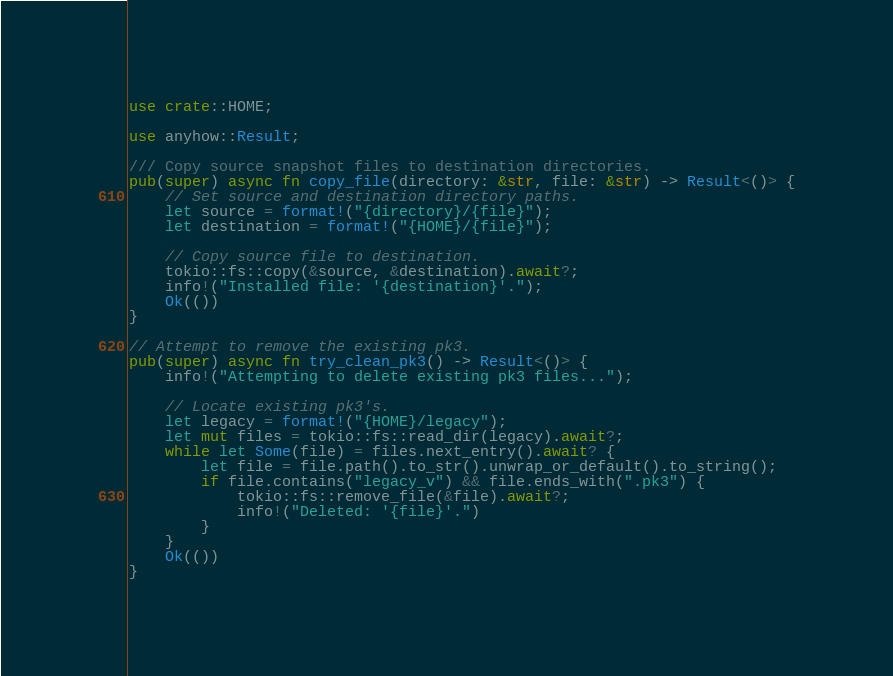Convert code to text. <code><loc_0><loc_0><loc_500><loc_500><_Rust_>use crate::HOME;

use anyhow::Result;

/// Copy source snapshot files to destination directories.
pub(super) async fn copy_file(directory: &str, file: &str) -> Result<()> {
    // Set source and destination directory paths.
    let source = format!("{directory}/{file}");
    let destination = format!("{HOME}/{file}");

    // Copy source file to destination.
    tokio::fs::copy(&source, &destination).await?;
    info!("Installed file: '{destination}'.");
    Ok(())
}

// Attempt to remove the existing pk3.
pub(super) async fn try_clean_pk3() -> Result<()> {
    info!("Attempting to delete existing pk3 files...");

    // Locate existing pk3's.
    let legacy = format!("{HOME}/legacy");
    let mut files = tokio::fs::read_dir(legacy).await?;
    while let Some(file) = files.next_entry().await? {
        let file = file.path().to_str().unwrap_or_default().to_string();
        if file.contains("legacy_v") && file.ends_with(".pk3") {
            tokio::fs::remove_file(&file).await?;
            info!("Deleted: '{file}'.")
        }
    }
    Ok(())
}
</code> 